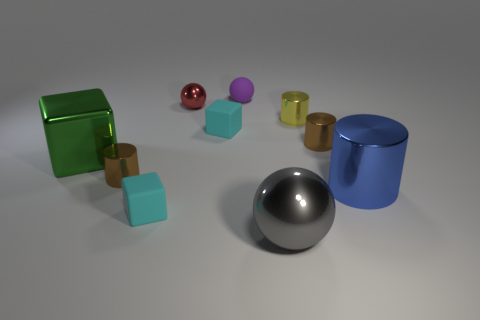Subtract all blue cylinders. How many cylinders are left? 3 Subtract 1 blocks. How many blocks are left? 2 Subtract all metal cubes. How many cubes are left? 2 Subtract all purple cylinders. Subtract all green balls. How many cylinders are left? 4 Subtract all spheres. How many objects are left? 7 Add 9 red metallic objects. How many red metallic objects are left? 10 Add 5 blue cylinders. How many blue cylinders exist? 6 Subtract 0 gray cubes. How many objects are left? 10 Subtract all small brown shiny things. Subtract all big cubes. How many objects are left? 7 